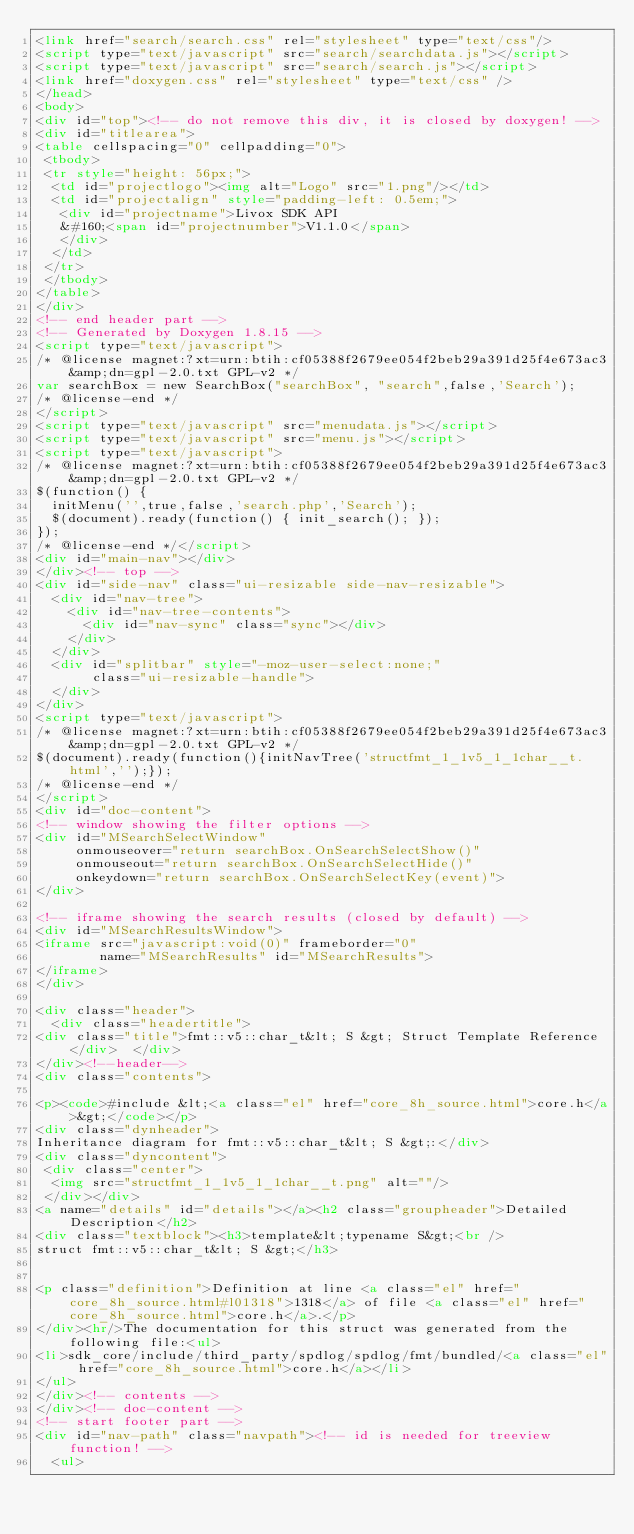<code> <loc_0><loc_0><loc_500><loc_500><_HTML_><link href="search/search.css" rel="stylesheet" type="text/css"/>
<script type="text/javascript" src="search/searchdata.js"></script>
<script type="text/javascript" src="search/search.js"></script>
<link href="doxygen.css" rel="stylesheet" type="text/css" />
</head>
<body>
<div id="top"><!-- do not remove this div, it is closed by doxygen! -->
<div id="titlearea">
<table cellspacing="0" cellpadding="0">
 <tbody>
 <tr style="height: 56px;">
  <td id="projectlogo"><img alt="Logo" src="1.png"/></td>
  <td id="projectalign" style="padding-left: 0.5em;">
   <div id="projectname">Livox SDK API
   &#160;<span id="projectnumber">V1.1.0</span>
   </div>
  </td>
 </tr>
 </tbody>
</table>
</div>
<!-- end header part -->
<!-- Generated by Doxygen 1.8.15 -->
<script type="text/javascript">
/* @license magnet:?xt=urn:btih:cf05388f2679ee054f2beb29a391d25f4e673ac3&amp;dn=gpl-2.0.txt GPL-v2 */
var searchBox = new SearchBox("searchBox", "search",false,'Search');
/* @license-end */
</script>
<script type="text/javascript" src="menudata.js"></script>
<script type="text/javascript" src="menu.js"></script>
<script type="text/javascript">
/* @license magnet:?xt=urn:btih:cf05388f2679ee054f2beb29a391d25f4e673ac3&amp;dn=gpl-2.0.txt GPL-v2 */
$(function() {
  initMenu('',true,false,'search.php','Search');
  $(document).ready(function() { init_search(); });
});
/* @license-end */</script>
<div id="main-nav"></div>
</div><!-- top -->
<div id="side-nav" class="ui-resizable side-nav-resizable">
  <div id="nav-tree">
    <div id="nav-tree-contents">
      <div id="nav-sync" class="sync"></div>
    </div>
  </div>
  <div id="splitbar" style="-moz-user-select:none;" 
       class="ui-resizable-handle">
  </div>
</div>
<script type="text/javascript">
/* @license magnet:?xt=urn:btih:cf05388f2679ee054f2beb29a391d25f4e673ac3&amp;dn=gpl-2.0.txt GPL-v2 */
$(document).ready(function(){initNavTree('structfmt_1_1v5_1_1char__t.html','');});
/* @license-end */
</script>
<div id="doc-content">
<!-- window showing the filter options -->
<div id="MSearchSelectWindow"
     onmouseover="return searchBox.OnSearchSelectShow()"
     onmouseout="return searchBox.OnSearchSelectHide()"
     onkeydown="return searchBox.OnSearchSelectKey(event)">
</div>

<!-- iframe showing the search results (closed by default) -->
<div id="MSearchResultsWindow">
<iframe src="javascript:void(0)" frameborder="0" 
        name="MSearchResults" id="MSearchResults">
</iframe>
</div>

<div class="header">
  <div class="headertitle">
<div class="title">fmt::v5::char_t&lt; S &gt; Struct Template Reference</div>  </div>
</div><!--header-->
<div class="contents">

<p><code>#include &lt;<a class="el" href="core_8h_source.html">core.h</a>&gt;</code></p>
<div class="dynheader">
Inheritance diagram for fmt::v5::char_t&lt; S &gt;:</div>
<div class="dyncontent">
 <div class="center">
  <img src="structfmt_1_1v5_1_1char__t.png" alt=""/>
 </div></div>
<a name="details" id="details"></a><h2 class="groupheader">Detailed Description</h2>
<div class="textblock"><h3>template&lt;typename S&gt;<br />
struct fmt::v5::char_t&lt; S &gt;</h3>


<p class="definition">Definition at line <a class="el" href="core_8h_source.html#l01318">1318</a> of file <a class="el" href="core_8h_source.html">core.h</a>.</p>
</div><hr/>The documentation for this struct was generated from the following file:<ul>
<li>sdk_core/include/third_party/spdlog/spdlog/fmt/bundled/<a class="el" href="core_8h_source.html">core.h</a></li>
</ul>
</div><!-- contents -->
</div><!-- doc-content -->
<!-- start footer part -->
<div id="nav-path" class="navpath"><!-- id is needed for treeview function! -->
  <ul></code> 